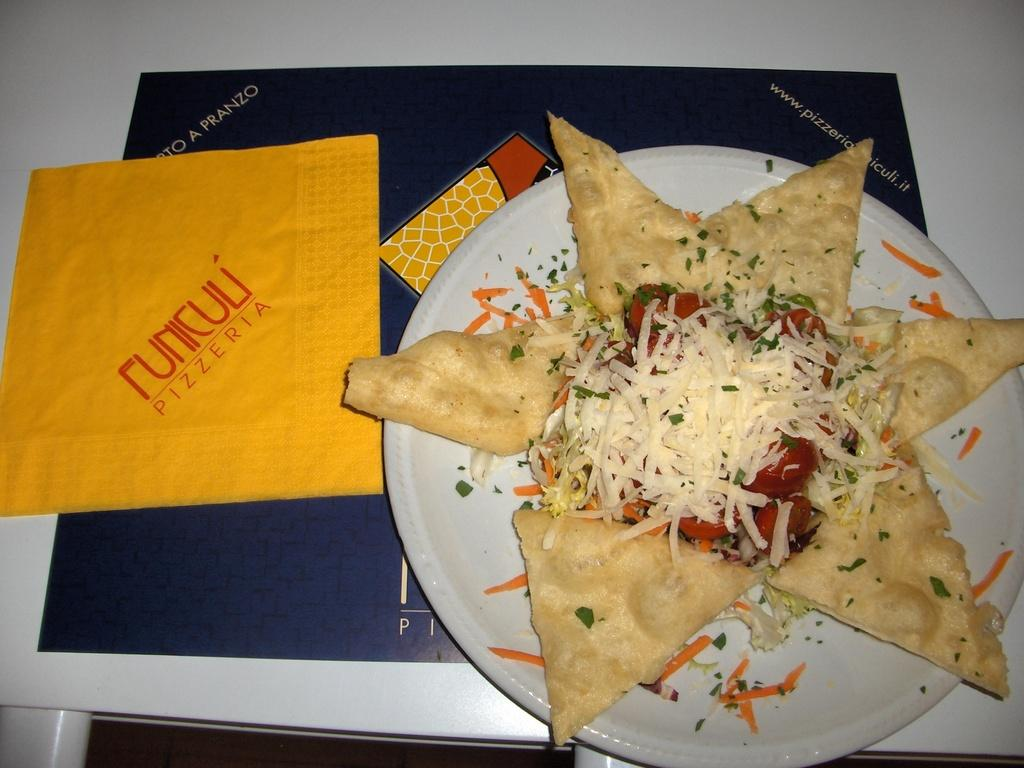<image>
Create a compact narrative representing the image presented. Funiculi Pizzeria serves a very appetizing and unusual looking star shaped pizza. 